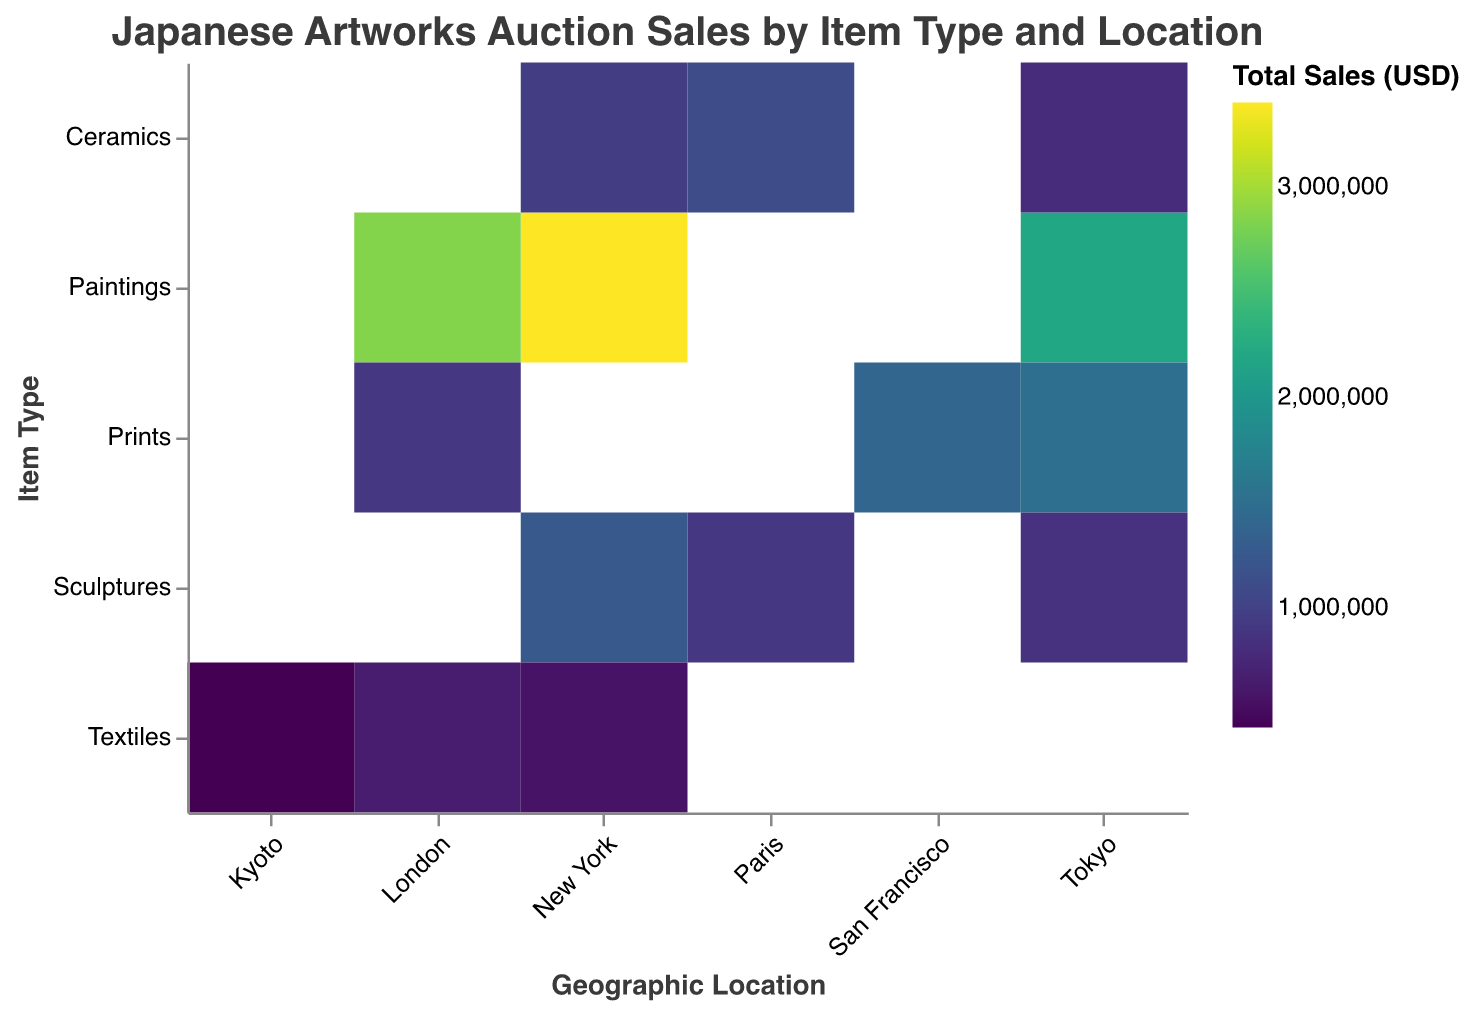What is the total sales value of Textiles in Kyoto? To find this, locate the cell corresponding to "Textiles" in the "Item Type" column and "Kyoto" in the "Geographic Location" column. The value within this cell is the total sales.
Answer: 430000 Which item type has the highest total sales in New York? Look at the "Item Type" associated with each "Geographic Location" that has "New York," then find the highest sales value among them. Compare Paintings (3400000 USD), Sculptures (1250000 USD), Ceramics (950000 USD), and Textiles (570000 USD).
Answer: Paintings What is the sum of total sales for Paintings across all locations? Add the sales values for Paintings across all locations: New York (3400000 USD), London (2850000 USD), and Tokyo (2200000 USD). The sum is 3400000 + 2850000 + 2200000.
Answer: 8450000 Which geographic location has the highest total sales for Prints? Look at the sales values for Prints across all locations: San Francisco (1400000 USD), London (900000 USD), and Tokyo (1500000 USD). Then identify the highest value.
Answer: Tokyo What is the difference in total sales of Sculptures between New York and Paris? Find the sales values for Sculptures in New York (1250000 USD) and Paris (900000 USD), then subtract the smaller value from the larger value: 1250000 - 900000.
Answer: 350000 Which item type has the least total sales in London? Examine the sales values for each item type in London: Paintings (2850000 USD), Prints (900000 USD), and Textiles (650000 USD). Identify the smallest value.
Answer: Textiles What is the average total sales value for Ceramics across all geographic locations? Add up the total sales values for Ceramics across all locations and divide by the number of locations: Paris (1100000 USD), New York (950000 USD), and Tokyo (800000 USD). The sum is 1100000 + 950000 + 800000 = 2850000, and the average is 2850000 / 3.
Answer: 950000 How many unique geographic locations are represented in the heatmap? Count the number of distinct geographic locations in the dataset: New York, London, Tokyo, San Francisco, Paris, Kyoto.
Answer: 6 In which location are the total sales for Textiles the highest? Check the sales values for Textiles across all locations: London (650000 USD), New York (570000 USD), and Kyoto (430000 USD). Identify the highest value.
Answer: London What is the total sales value for all item types in Tokyo? Sum the sales values for each item type in Tokyo: Paintings (2200000 USD), Prints (1500000 USD), Sculptures (850000 USD), and Ceramics (800000 USD). The sum is 2200000 + 1500000 + 850000 + 800000.
Answer: 5350000 